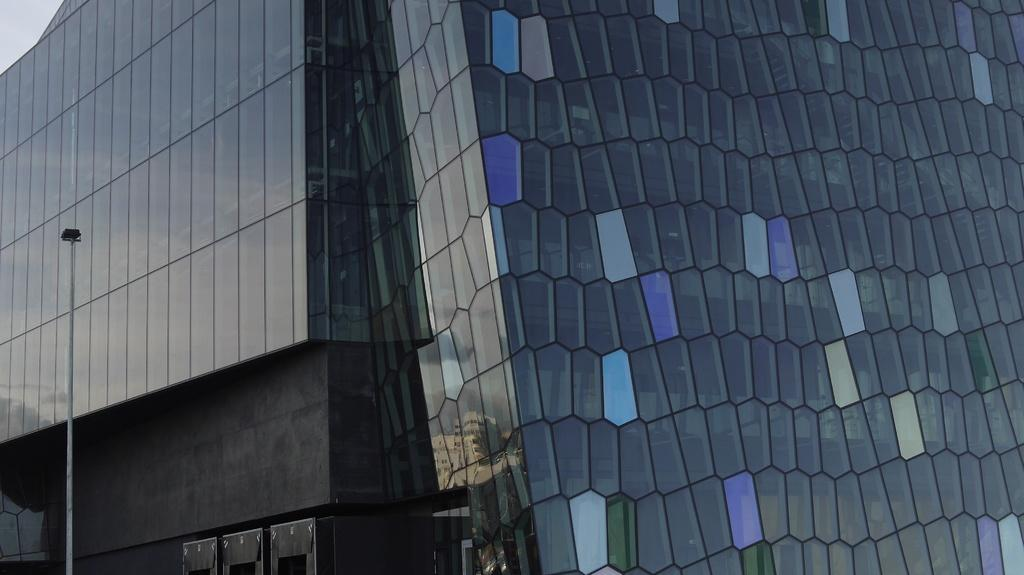What type of building is depicted in the image? There is a glass building in the image. Are there any other structures or objects in the image? Yes, there is a light pole in the image. What is the color of the building? The building is in gray color. What can be seen in the background of the image? The sky is in white color in the background. Where is the nest located in the image? There is no nest present in the image. What type of oil can be seen dripping from the light pole in the image? There is no oil present in the image, nor is there any indication of dripping oil from the light pole. 